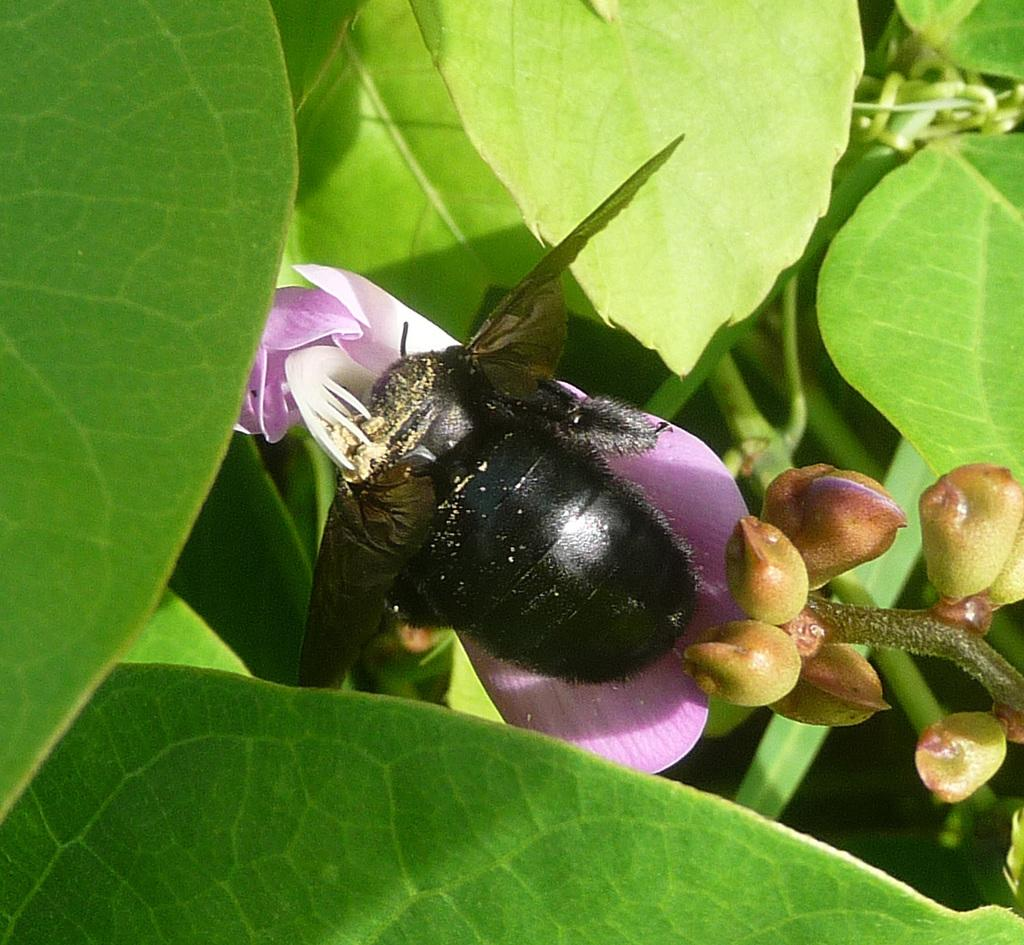What type of plant material is present in the image? There are leaves in the image. What is the insect doing in the image? The insect is on a flower in the image. What stage of growth are some of the plants in the image? There are buds in the image, which are a stage of growth before flowers bloom. What type of book can be seen in the image? There is no book present in the image; it features leaves, an insect, and buds. What rhythm is the insect following as it moves on the flower? The image does not provide information about the insect's movement or any rhythm it might be following. 